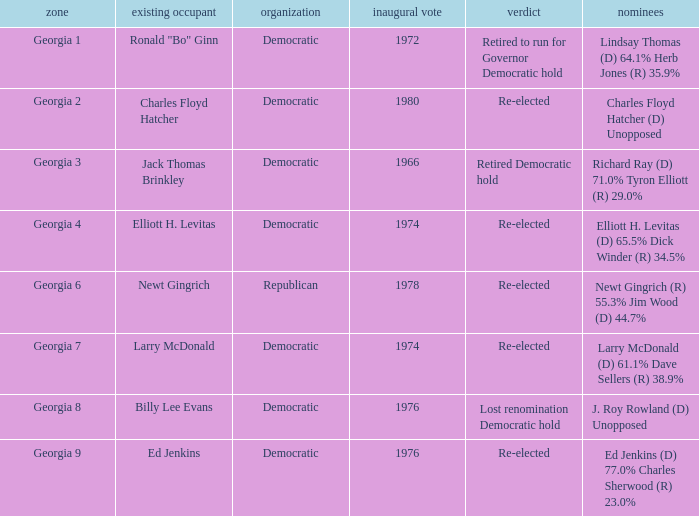Name the party of georgia 4 Democratic. 